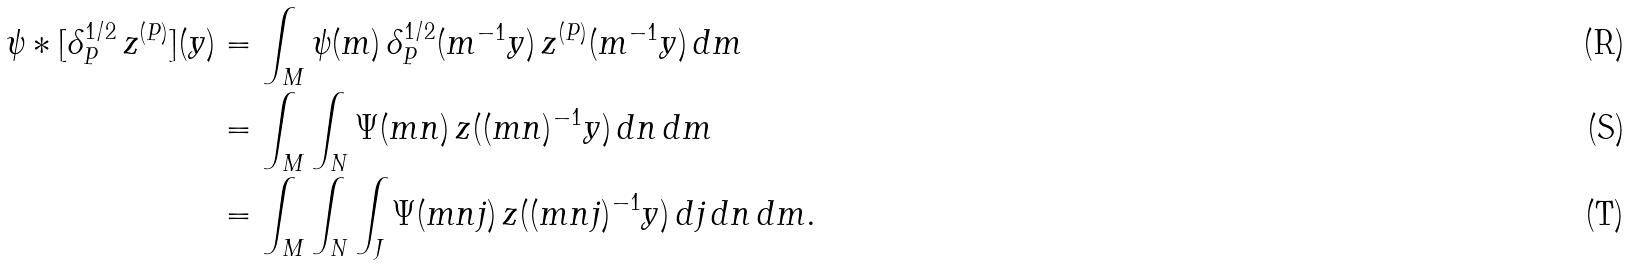Convert formula to latex. <formula><loc_0><loc_0><loc_500><loc_500>\psi * [ \delta _ { P } ^ { 1 / 2 } \, z ^ { ( P ) } ] ( y ) & = \int _ { M } \psi ( m ) \, \delta _ { P } ^ { 1 / 2 } ( m ^ { - 1 } y ) \, z ^ { ( P ) } ( m ^ { - 1 } y ) \, d m \\ & = \int _ { M } \int _ { N } \Psi ( m n ) \, z ( ( m n ) ^ { - 1 } y ) \, d n \, d m \\ & = \int _ { M } \int _ { N } \int _ { J } \Psi ( m n j ) \, z ( ( m n j ) ^ { - 1 } y ) \, d j \, d n \, d m .</formula> 